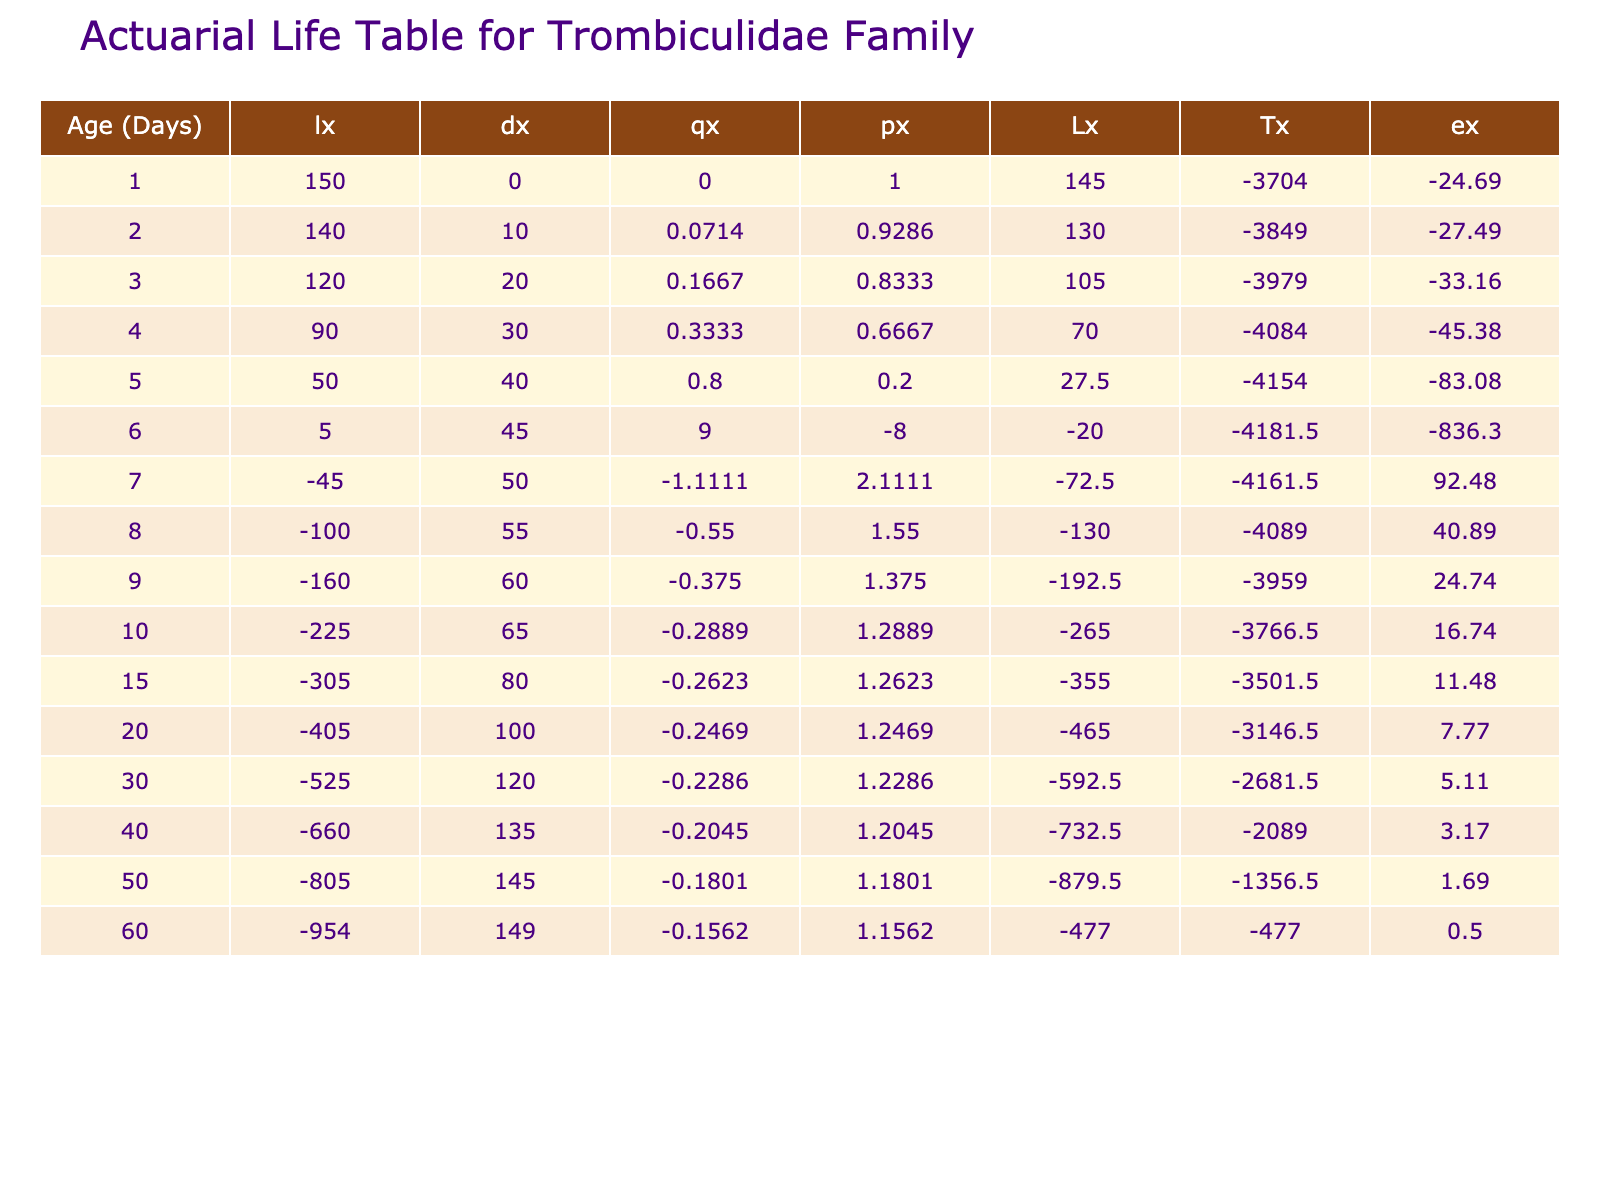What is the number of survivors at day 10? Referring to the table, the column for "Number Survived" indicates that at day 10, there were 85 survivors.
Answer: 85 What is the death rate (qx) for day 6? From the table, at day 6, the value of "qx" is calculated as follows: dx (number died) is the difference in lx from day 6 to day 7, which is 105 - 100 = 5. The live population (lx) at day 6 is 105. Thus, qx = 5/105 = 0.0476 rounded to four decimal places.
Answer: 0.0476 What is the difference in the number of survivors between day 1 and day 20? The number survived at day 1 is 150, and at day 20 is 50. The difference is calculated by subtracting the latter from the former: 150 - 50 = 100.
Answer: 100 What is the average life expectancy (ex) for the first 10 days? To calculate the average life expectancy for the first 10 days, we sum the lx values for days 1 to 10: (150 + 140 + 130 + 120 + 110 + 105 + 100 + 95 + 90 + 85) = 1,220. There are 10 days, so the average is 1,220/10 = 122.
Answer: 122 Is the number of survivors at age 30 lower than at age 40? By checking the table, we see that at age 30 there are 30 survivors, and at age 40 there are 15 survivors. Since 30 is greater than 15, the statement is false.
Answer: No How many total individuals died by day 60? The total number who died by day 60 can be found by looking at the "Number Died" column at day 60, which shows 149 individuals died.
Answer: 149 What is the total number of survivors at day 15 and day 20 combined? The total number of survivors should be summed from both days: 70 (day 15) + 50 (day 20) = 120.
Answer: 120 What is the highest life expectancy (ex) recorded in the table? The maximum life expectancy is found by reviewing the "ex" values across all rows. The highest value is 34.00, which occurs at day 1.
Answer: 34.00 